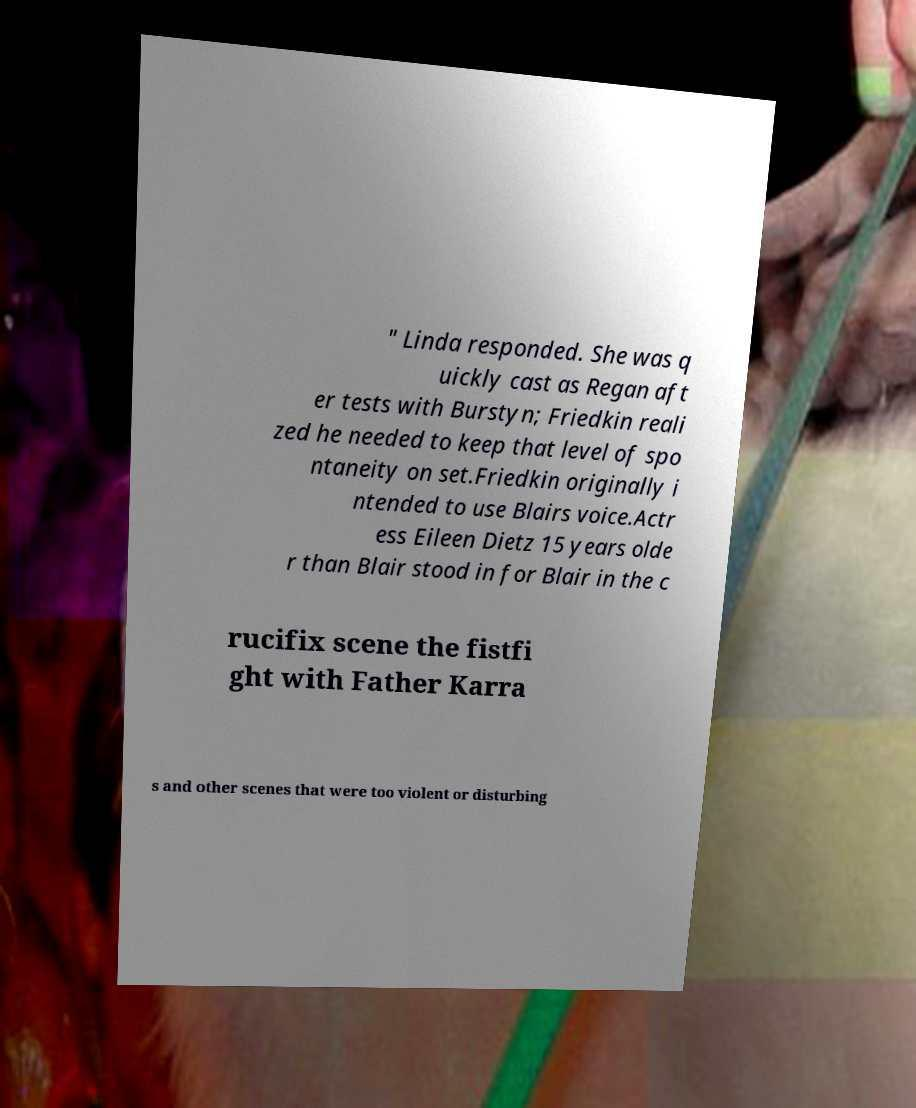Can you accurately transcribe the text from the provided image for me? " Linda responded. She was q uickly cast as Regan aft er tests with Burstyn; Friedkin reali zed he needed to keep that level of spo ntaneity on set.Friedkin originally i ntended to use Blairs voice.Actr ess Eileen Dietz 15 years olde r than Blair stood in for Blair in the c rucifix scene the fistfi ght with Father Karra s and other scenes that were too violent or disturbing 